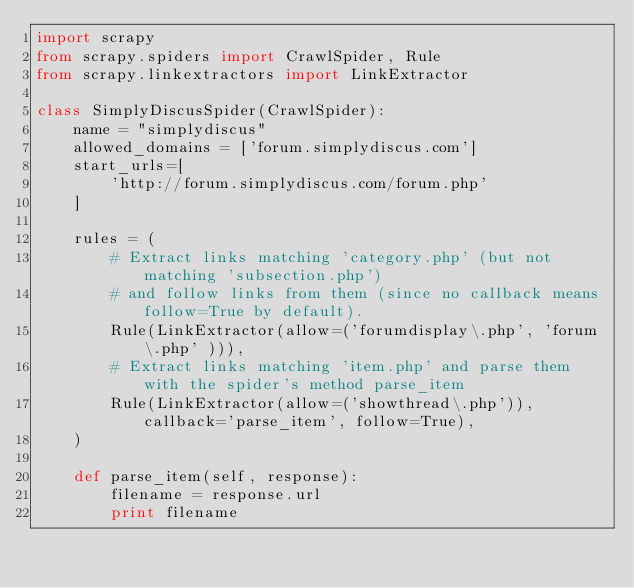<code> <loc_0><loc_0><loc_500><loc_500><_Python_>import scrapy
from scrapy.spiders import CrawlSpider, Rule
from scrapy.linkextractors import LinkExtractor

class SimplyDiscusSpider(CrawlSpider):
    name = "simplydiscus"
    allowed_domains = ['forum.simplydiscus.com']
    start_urls=[
        'http://forum.simplydiscus.com/forum.php'
    ]

    rules = (
        # Extract links matching 'category.php' (but not matching 'subsection.php')
        # and follow links from them (since no callback means follow=True by default).
        Rule(LinkExtractor(allow=('forumdisplay\.php', 'forum\.php' ))),
        # Extract links matching 'item.php' and parse them with the spider's method parse_item
        Rule(LinkExtractor(allow=('showthread\.php')), callback='parse_item', follow=True),
    )

    def parse_item(self, response):
        filename = response.url
        print filename
</code> 